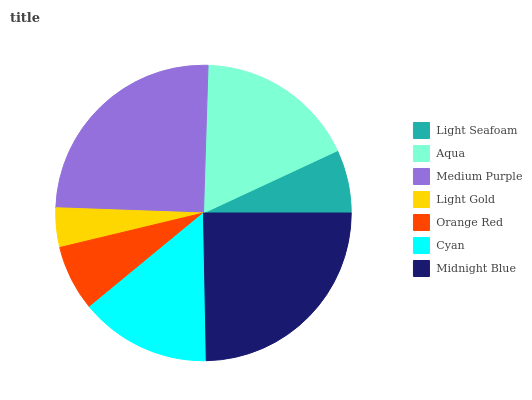Is Light Gold the minimum?
Answer yes or no. Yes. Is Medium Purple the maximum?
Answer yes or no. Yes. Is Aqua the minimum?
Answer yes or no. No. Is Aqua the maximum?
Answer yes or no. No. Is Aqua greater than Light Seafoam?
Answer yes or no. Yes. Is Light Seafoam less than Aqua?
Answer yes or no. Yes. Is Light Seafoam greater than Aqua?
Answer yes or no. No. Is Aqua less than Light Seafoam?
Answer yes or no. No. Is Cyan the high median?
Answer yes or no. Yes. Is Cyan the low median?
Answer yes or no. Yes. Is Midnight Blue the high median?
Answer yes or no. No. Is Light Gold the low median?
Answer yes or no. No. 